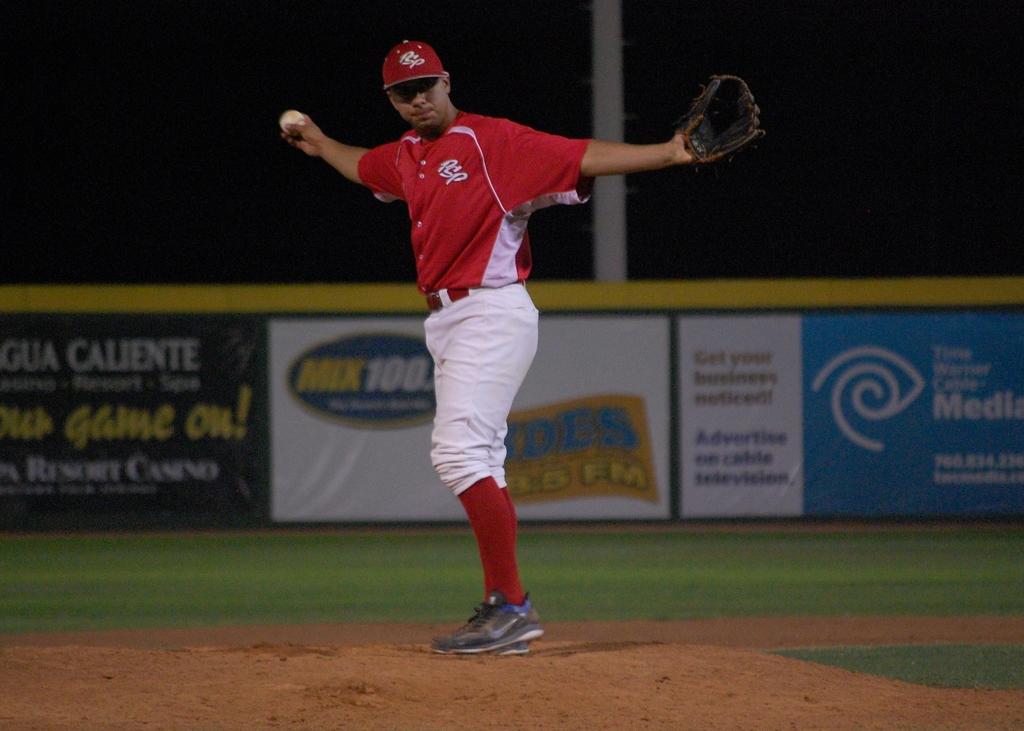What internet company is advertised on the right?
Provide a short and direct response. Time warner cable. 